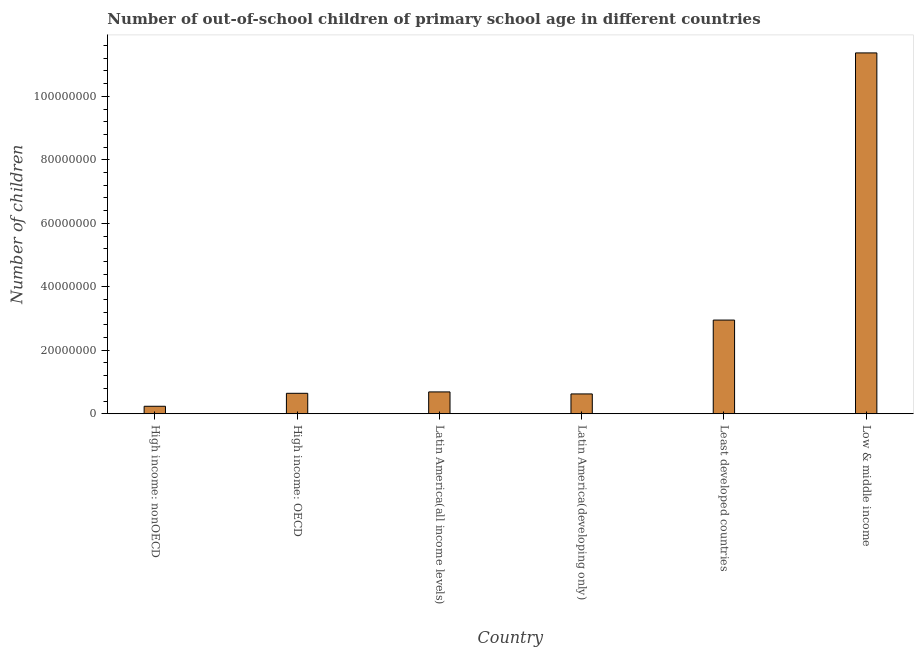Does the graph contain any zero values?
Provide a short and direct response. No. Does the graph contain grids?
Your answer should be compact. No. What is the title of the graph?
Provide a succinct answer. Number of out-of-school children of primary school age in different countries. What is the label or title of the Y-axis?
Your answer should be very brief. Number of children. What is the number of out-of-school children in Latin America(all income levels)?
Provide a succinct answer. 6.88e+06. Across all countries, what is the maximum number of out-of-school children?
Provide a succinct answer. 1.14e+08. Across all countries, what is the minimum number of out-of-school children?
Provide a short and direct response. 2.35e+06. In which country was the number of out-of-school children minimum?
Give a very brief answer. High income: nonOECD. What is the sum of the number of out-of-school children?
Give a very brief answer. 1.65e+08. What is the difference between the number of out-of-school children in High income: OECD and Latin America(all income levels)?
Provide a short and direct response. -4.39e+05. What is the average number of out-of-school children per country?
Provide a succinct answer. 2.75e+07. What is the median number of out-of-school children?
Provide a short and direct response. 6.66e+06. What is the ratio of the number of out-of-school children in High income: OECD to that in Latin America(developing only)?
Offer a terse response. 1.03. Is the number of out-of-school children in High income: nonOECD less than that in Low & middle income?
Provide a short and direct response. Yes. Is the difference between the number of out-of-school children in Latin America(developing only) and Low & middle income greater than the difference between any two countries?
Your answer should be very brief. No. What is the difference between the highest and the second highest number of out-of-school children?
Provide a succinct answer. 8.42e+07. Is the sum of the number of out-of-school children in High income: nonOECD and Latin America(developing only) greater than the maximum number of out-of-school children across all countries?
Keep it short and to the point. No. What is the difference between the highest and the lowest number of out-of-school children?
Make the answer very short. 1.11e+08. In how many countries, is the number of out-of-school children greater than the average number of out-of-school children taken over all countries?
Provide a short and direct response. 2. How many bars are there?
Ensure brevity in your answer.  6. What is the Number of children in High income: nonOECD?
Offer a very short reply. 2.35e+06. What is the Number of children in High income: OECD?
Your answer should be very brief. 6.44e+06. What is the Number of children of Latin America(all income levels)?
Ensure brevity in your answer.  6.88e+06. What is the Number of children in Latin America(developing only)?
Offer a very short reply. 6.24e+06. What is the Number of children of Least developed countries?
Give a very brief answer. 2.95e+07. What is the Number of children of Low & middle income?
Provide a succinct answer. 1.14e+08. What is the difference between the Number of children in High income: nonOECD and High income: OECD?
Your response must be concise. -4.08e+06. What is the difference between the Number of children in High income: nonOECD and Latin America(all income levels)?
Keep it short and to the point. -4.52e+06. What is the difference between the Number of children in High income: nonOECD and Latin America(developing only)?
Provide a succinct answer. -3.89e+06. What is the difference between the Number of children in High income: nonOECD and Least developed countries?
Keep it short and to the point. -2.72e+07. What is the difference between the Number of children in High income: nonOECD and Low & middle income?
Your response must be concise. -1.11e+08. What is the difference between the Number of children in High income: OECD and Latin America(all income levels)?
Keep it short and to the point. -4.39e+05. What is the difference between the Number of children in High income: OECD and Latin America(developing only)?
Give a very brief answer. 1.95e+05. What is the difference between the Number of children in High income: OECD and Least developed countries?
Your answer should be very brief. -2.31e+07. What is the difference between the Number of children in High income: OECD and Low & middle income?
Provide a short and direct response. -1.07e+08. What is the difference between the Number of children in Latin America(all income levels) and Latin America(developing only)?
Ensure brevity in your answer.  6.34e+05. What is the difference between the Number of children in Latin America(all income levels) and Least developed countries?
Provide a short and direct response. -2.26e+07. What is the difference between the Number of children in Latin America(all income levels) and Low & middle income?
Your answer should be compact. -1.07e+08. What is the difference between the Number of children in Latin America(developing only) and Least developed countries?
Your answer should be compact. -2.33e+07. What is the difference between the Number of children in Latin America(developing only) and Low & middle income?
Your answer should be compact. -1.07e+08. What is the difference between the Number of children in Least developed countries and Low & middle income?
Your answer should be compact. -8.42e+07. What is the ratio of the Number of children in High income: nonOECD to that in High income: OECD?
Provide a short and direct response. 0.37. What is the ratio of the Number of children in High income: nonOECD to that in Latin America(all income levels)?
Give a very brief answer. 0.34. What is the ratio of the Number of children in High income: nonOECD to that in Latin America(developing only)?
Offer a very short reply. 0.38. What is the ratio of the Number of children in High income: nonOECD to that in Low & middle income?
Your response must be concise. 0.02. What is the ratio of the Number of children in High income: OECD to that in Latin America(all income levels)?
Provide a succinct answer. 0.94. What is the ratio of the Number of children in High income: OECD to that in Latin America(developing only)?
Your answer should be compact. 1.03. What is the ratio of the Number of children in High income: OECD to that in Least developed countries?
Provide a short and direct response. 0.22. What is the ratio of the Number of children in High income: OECD to that in Low & middle income?
Your response must be concise. 0.06. What is the ratio of the Number of children in Latin America(all income levels) to that in Latin America(developing only)?
Provide a succinct answer. 1.1. What is the ratio of the Number of children in Latin America(all income levels) to that in Least developed countries?
Offer a very short reply. 0.23. What is the ratio of the Number of children in Latin America(developing only) to that in Least developed countries?
Ensure brevity in your answer.  0.21. What is the ratio of the Number of children in Latin America(developing only) to that in Low & middle income?
Ensure brevity in your answer.  0.06. What is the ratio of the Number of children in Least developed countries to that in Low & middle income?
Your answer should be compact. 0.26. 